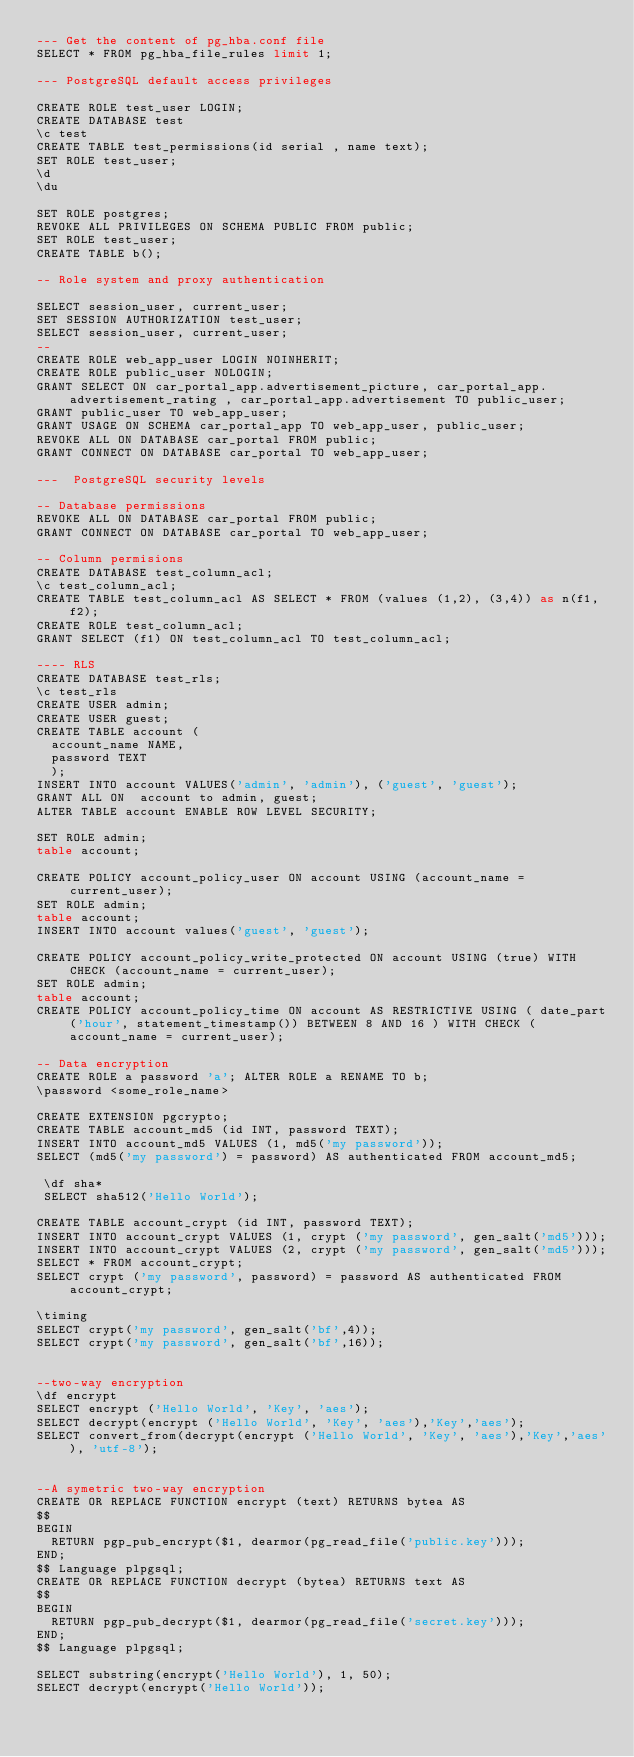<code> <loc_0><loc_0><loc_500><loc_500><_SQL_>--- Get the content of pg_hba.conf file
SELECT * FROM pg_hba_file_rules limit 1;

--- PostgreSQL default access privileges

CREATE ROLE test_user LOGIN;
CREATE DATABASE test
\c test
CREATE TABLE test_permissions(id serial , name text);
SET ROLE test_user;
\d
\du

SET ROLE postgres;
REVOKE ALL PRIVILEGES ON SCHEMA PUBLIC FROM public;
SET ROLE test_user;
CREATE TABLE b();

-- Role system and proxy authentication

SELECT session_user, current_user;
SET SESSION AUTHORIZATION test_user;
SELECT session_user, current_user;
--
CREATE ROLE web_app_user LOGIN NOINHERIT;
CREATE ROLE public_user NOLOGIN;
GRANT SELECT ON car_portal_app.advertisement_picture, car_portal_app.advertisement_rating , car_portal_app.advertisement TO public_user;
GRANT public_user TO web_app_user;
GRANT USAGE ON SCHEMA car_portal_app TO web_app_user, public_user;
REVOKE ALL ON DATABASE car_portal FROM public;
GRANT CONNECT ON DATABASE car_portal TO web_app_user;

---  PostgreSQL security levels

-- Database permissions
REVOKE ALL ON DATABASE car_portal FROM public;
GRANT CONNECT ON DATABASE car_portal TO web_app_user;

-- Column permisions
CREATE DATABASE test_column_acl;
\c test_column_acl;
CREATE TABLE test_column_acl AS SELECT * FROM (values (1,2), (3,4)) as n(f1, f2);
CREATE ROLE test_column_acl;
GRANT SELECT (f1) ON test_column_acl TO test_column_acl;

---- RLS
CREATE DATABASE test_rls;
\c test_rls
CREATE USER admin;
CREATE USER guest;
CREATE TABLE account (
  account_name NAME,
  password TEXT
  );
INSERT INTO account VALUES('admin', 'admin'), ('guest', 'guest');
GRANT ALL ON  account to admin, guest;
ALTER TABLE account ENABLE ROW LEVEL SECURITY;

SET ROLE admin;
table account;

CREATE POLICY account_policy_user ON account USING (account_name = current_user);
SET ROLE admin;
table account;
INSERT INTO account values('guest', 'guest');

CREATE POLICY account_policy_write_protected ON account USING (true) WITH CHECK (account_name = current_user);
SET ROLE admin;
table account;
CREATE POLICY account_policy_time ON account AS RESTRICTIVE USING ( date_part('hour', statement_timestamp()) BETWEEN 8 AND 16 ) WITH CHECK (account_name = current_user);

-- Data encryption
CREATE ROLE a password 'a'; ALTER ROLE a RENAME TO b;
\password <some_role_name>

CREATE EXTENSION pgcrypto;
CREATE TABLE account_md5 (id INT, password TEXT);
INSERT INTO account_md5 VALUES (1, md5('my password'));
SELECT (md5('my password') = password) AS authenticated FROM account_md5;

 \df sha*
 SELECT sha512('Hello World');

CREATE TABLE account_crypt (id INT, password TEXT);
INSERT INTO account_crypt VALUES (1, crypt ('my password', gen_salt('md5')));
INSERT INTO account_crypt VALUES (2, crypt ('my password', gen_salt('md5')));
SELECT * FROM account_crypt;
SELECT crypt ('my password', password) = password AS authenticated FROM account_crypt;

\timing
SELECT crypt('my password', gen_salt('bf',4));
SELECT crypt('my password', gen_salt('bf',16));


--two-way encryption
\df encrypt
SELECT encrypt ('Hello World', 'Key', 'aes');
SELECT decrypt(encrypt ('Hello World', 'Key', 'aes'),'Key','aes');
SELECT convert_from(decrypt(encrypt ('Hello World', 'Key', 'aes'),'Key','aes'), 'utf-8');


--A symetric two-way encryption
CREATE OR REPLACE FUNCTION encrypt (text) RETURNS bytea AS
$$
BEGIN
  RETURN pgp_pub_encrypt($1, dearmor(pg_read_file('public.key')));
END;
$$ Language plpgsql;
CREATE OR REPLACE FUNCTION decrypt (bytea) RETURNS text AS
$$
BEGIN
  RETURN pgp_pub_decrypt($1, dearmor(pg_read_file('secret.key')));
END;
$$ Language plpgsql;

SELECT substring(encrypt('Hello World'), 1, 50);
SELECT decrypt(encrypt('Hello World'));</code> 